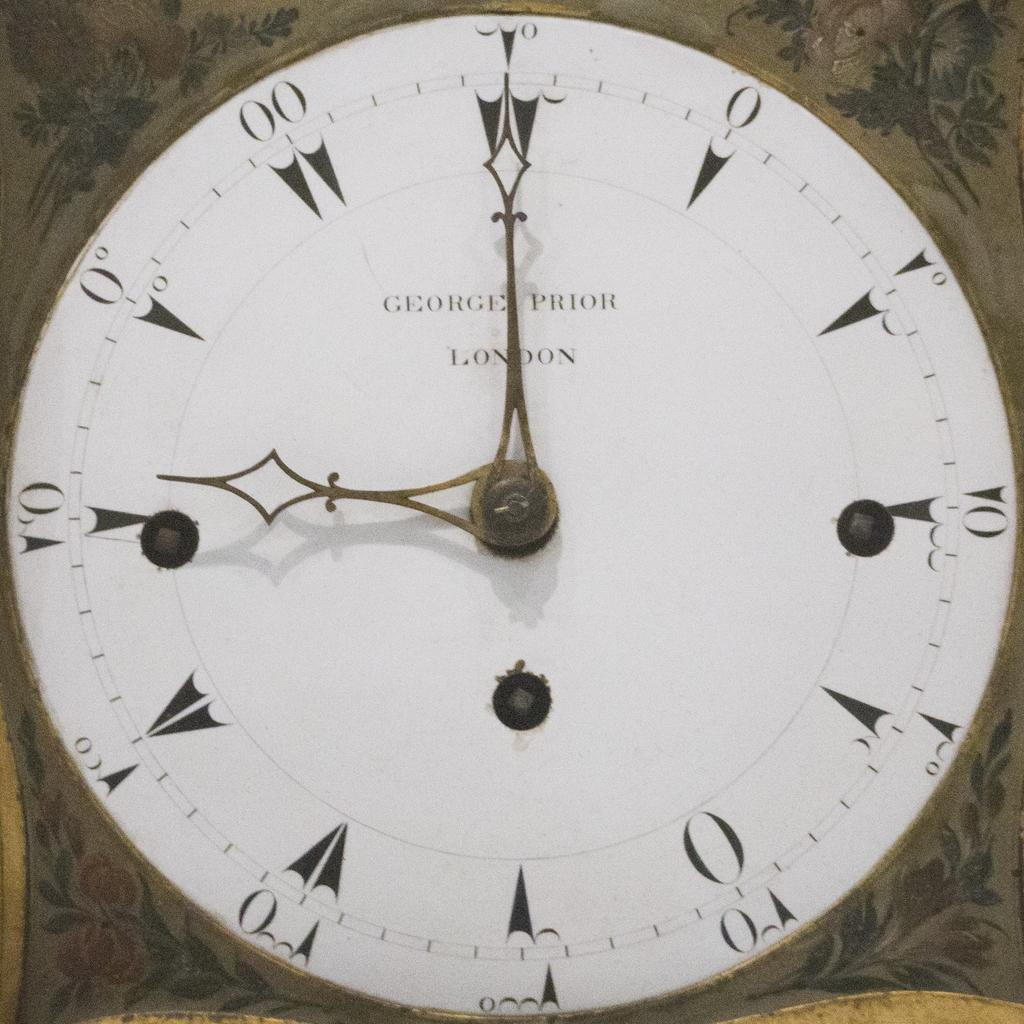Provide a one-sentence caption for the provided image. A George Prior London clock that says nine o clock. 